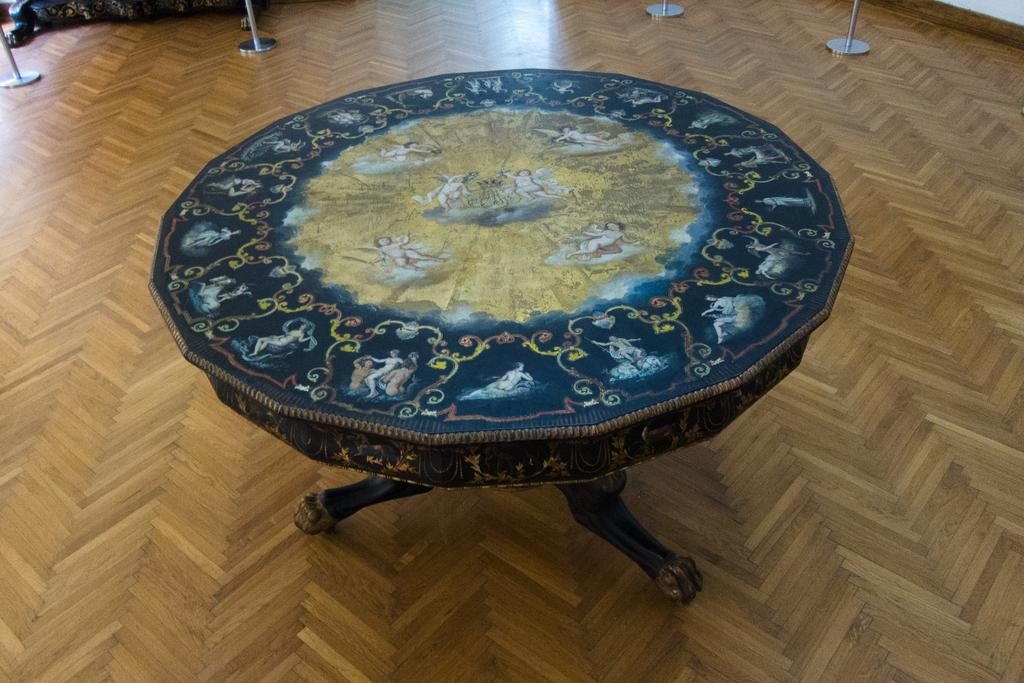Where was the image taken? The image was taken in a room. What is the main piece of furniture in the room? There is a wooden table in the center of the image. What other objects can be seen in the image? There are stands and a couch in the image. What material is the floor made of? The floor is made of wood. What type of breakfast is being served on the wooden table in the image? There is no breakfast visible in the image; it only shows a wooden table, stands, and a couch. Can you hear the people in the image laughing? There are no people or sounds of laughter present in the image. 